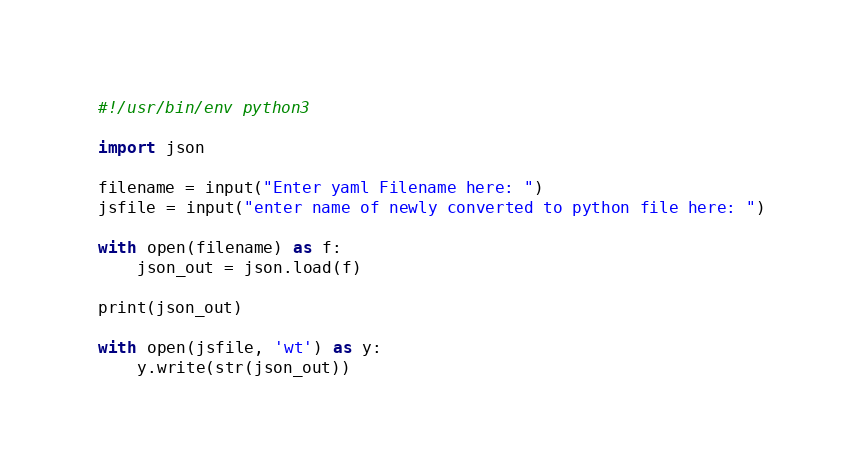Convert code to text. <code><loc_0><loc_0><loc_500><loc_500><_Python_>#!/usr/bin/env python3

import json

filename = input("Enter yaml Filename here: ")
jsfile = input("enter name of newly converted to python file here: ")

with open(filename) as f:
    json_out = json.load(f)

print(json_out)

with open(jsfile, 'wt') as y:
    y.write(str(json_out))

</code> 